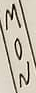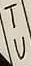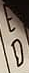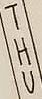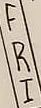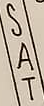What text appears in these images from left to right, separated by a semicolon? MON; TU; ED; THU; FRI; SAT 